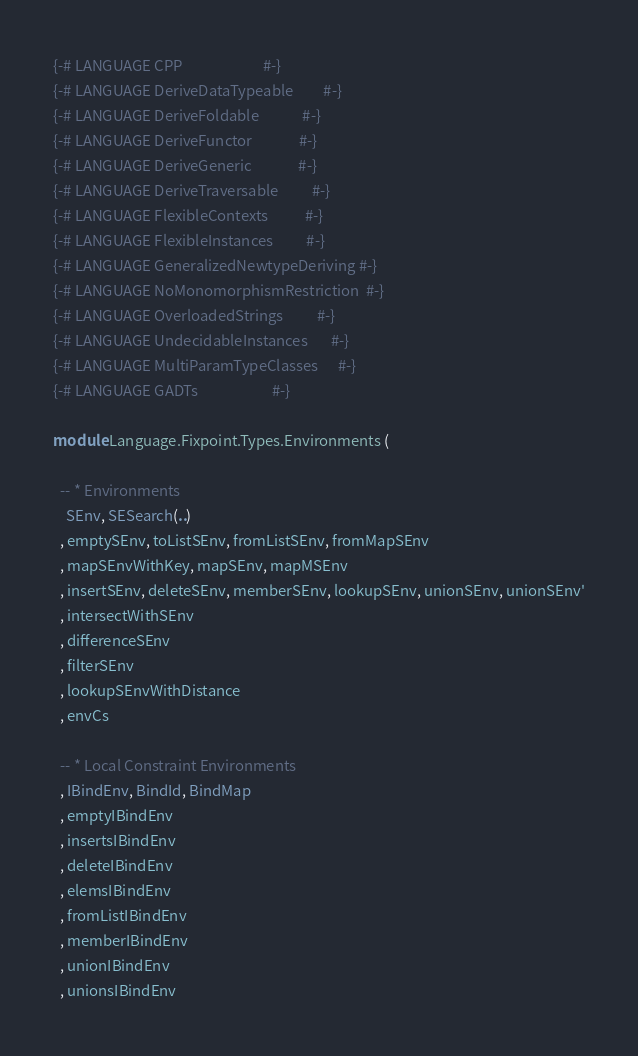Convert code to text. <code><loc_0><loc_0><loc_500><loc_500><_Haskell_>{-# LANGUAGE CPP                        #-}
{-# LANGUAGE DeriveDataTypeable         #-}
{-# LANGUAGE DeriveFoldable             #-}
{-# LANGUAGE DeriveFunctor              #-}
{-# LANGUAGE DeriveGeneric              #-}
{-# LANGUAGE DeriveTraversable          #-}
{-# LANGUAGE FlexibleContexts           #-}
{-# LANGUAGE FlexibleInstances          #-}
{-# LANGUAGE GeneralizedNewtypeDeriving #-}
{-# LANGUAGE NoMonomorphismRestriction  #-}
{-# LANGUAGE OverloadedStrings          #-}
{-# LANGUAGE UndecidableInstances       #-}
{-# LANGUAGE MultiParamTypeClasses      #-}
{-# LANGUAGE GADTs                      #-}

module Language.Fixpoint.Types.Environments (

  -- * Environments
    SEnv, SESearch(..)
  , emptySEnv, toListSEnv, fromListSEnv, fromMapSEnv
  , mapSEnvWithKey, mapSEnv, mapMSEnv
  , insertSEnv, deleteSEnv, memberSEnv, lookupSEnv, unionSEnv, unionSEnv'
  , intersectWithSEnv
  , differenceSEnv
  , filterSEnv
  , lookupSEnvWithDistance
  , envCs

  -- * Local Constraint Environments
  , IBindEnv, BindId, BindMap
  , emptyIBindEnv
  , insertsIBindEnv
  , deleteIBindEnv
  , elemsIBindEnv
  , fromListIBindEnv
  , memberIBindEnv
  , unionIBindEnv
  , unionsIBindEnv</code> 